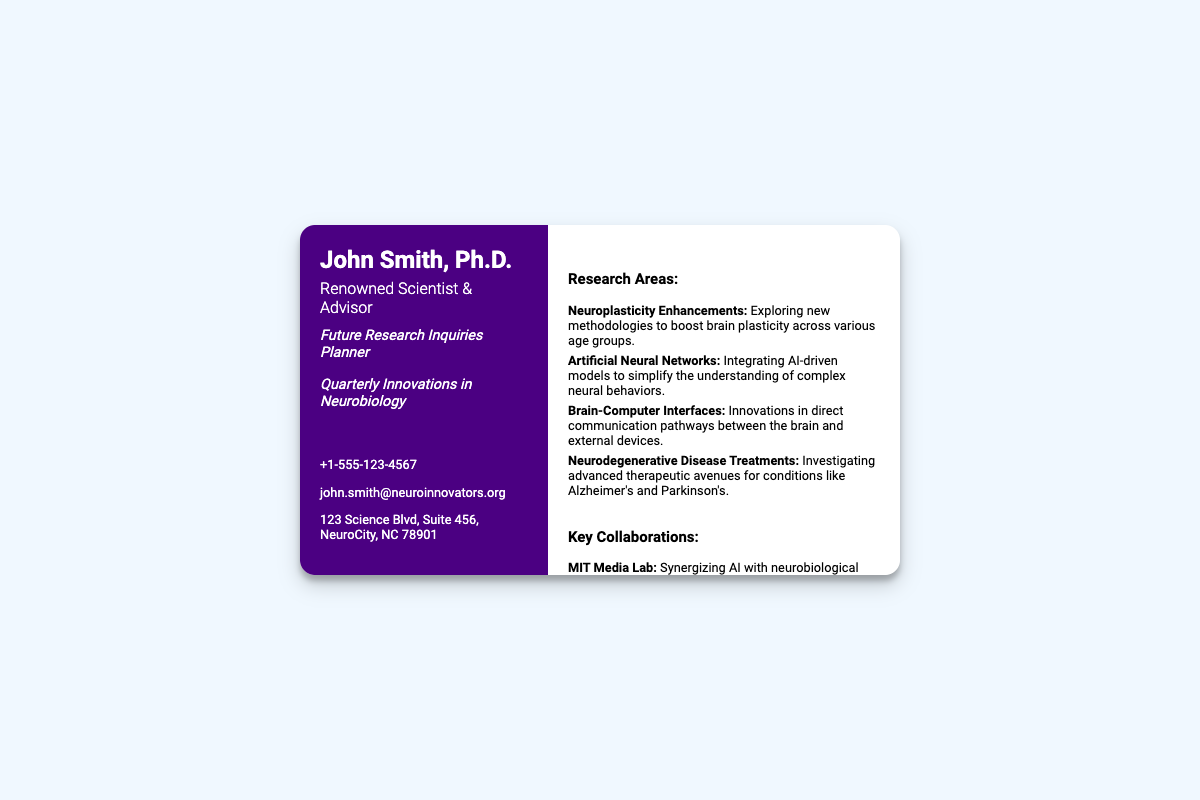what is the name of the scientist? The document identifies the scientist as "John Smith, Ph.D."
Answer: John Smith, Ph.D what is the main focus of this card? The card highlights two key themes: "Future Research Inquiries Planner" and "Quarterly Innovations in Neurobiology."
Answer: Future Research Inquiries Planner how many contact methods are provided? The document lists three contact methods: a phone number, email, and address.
Answer: 3 which university is mentioned as a key collaboration? The document lists "Johns Hopkins University" as a key collaborator.
Answer: Johns Hopkins University what is one area of research mentioned? The card outlines "Neuroplasticity Enhancements" as one of the research areas.
Answer: Neuroplasticity Enhancements who is collaborating with MIT Media Lab? The document states that "Synergizing AI with neurobiological research" is happening with MIT Media Lab.
Answer: MIT Media Lab which neurodegenerative disease is referenced? The document mentions "Alzheimer's" as a neurodegenerative disease in the context of treatment research.
Answer: Alzheimer's what is the tagline under the name? The tagline emphasizes "Future Research Inquiries Planner," indicating a focus on research strategy.
Answer: Future Research Inquiries Planner how many research areas are listed? The document features four different research areas relating to neurobiology.
Answer: 4 